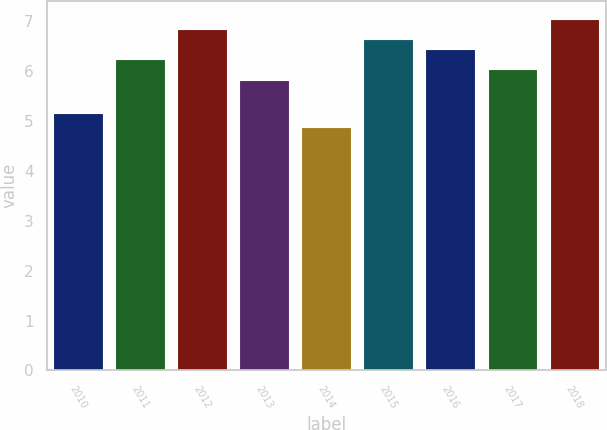<chart> <loc_0><loc_0><loc_500><loc_500><bar_chart><fcel>2010<fcel>2011<fcel>2012<fcel>2013<fcel>2014<fcel>2015<fcel>2016<fcel>2017<fcel>2018<nl><fcel>5.17<fcel>6.25<fcel>6.85<fcel>5.83<fcel>4.87<fcel>6.65<fcel>6.45<fcel>6.05<fcel>7.05<nl></chart> 